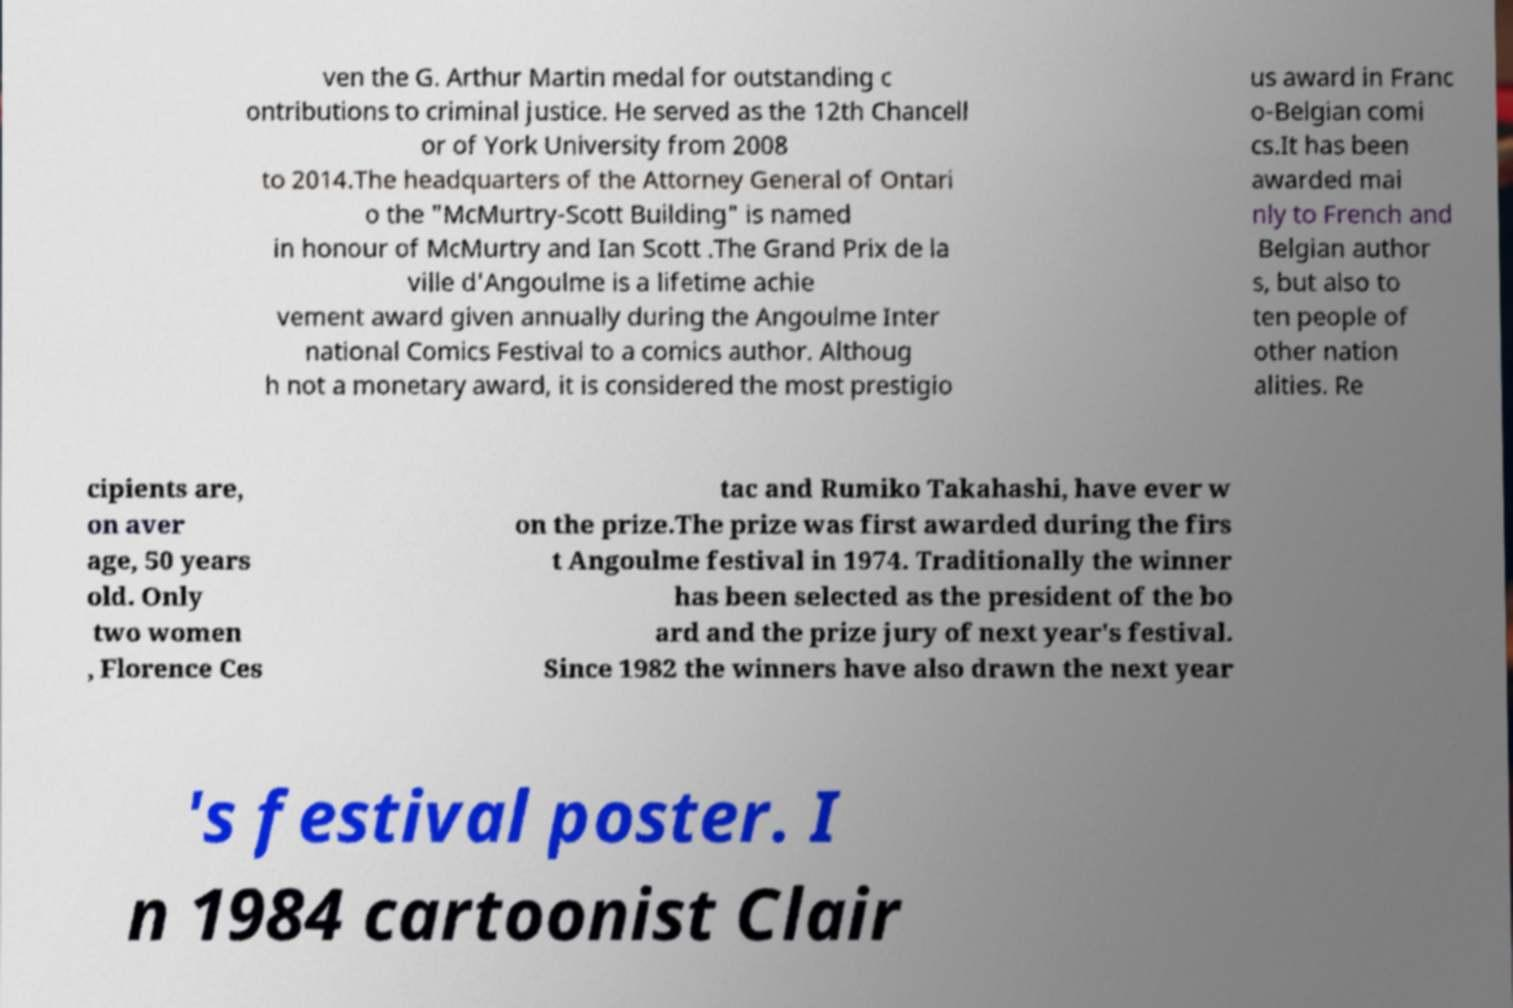Can you read and provide the text displayed in the image?This photo seems to have some interesting text. Can you extract and type it out for me? ven the G. Arthur Martin medal for outstanding c ontributions to criminal justice. He served as the 12th Chancell or of York University from 2008 to 2014.The headquarters of the Attorney General of Ontari o the "McMurtry-Scott Building" is named in honour of McMurtry and Ian Scott .The Grand Prix de la ville d'Angoulme is a lifetime achie vement award given annually during the Angoulme Inter national Comics Festival to a comics author. Althoug h not a monetary award, it is considered the most prestigio us award in Franc o-Belgian comi cs.It has been awarded mai nly to French and Belgian author s, but also to ten people of other nation alities. Re cipients are, on aver age, 50 years old. Only two women , Florence Ces tac and Rumiko Takahashi, have ever w on the prize.The prize was first awarded during the firs t Angoulme festival in 1974. Traditionally the winner has been selected as the president of the bo ard and the prize jury of next year's festival. Since 1982 the winners have also drawn the next year 's festival poster. I n 1984 cartoonist Clair 